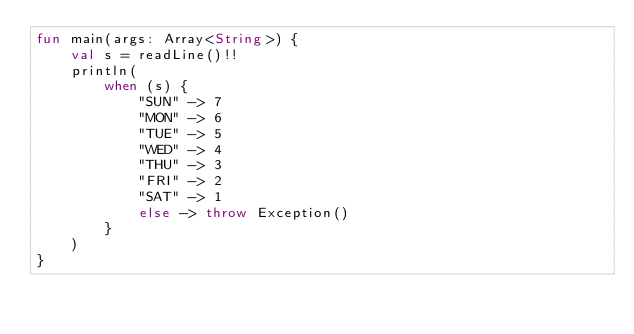<code> <loc_0><loc_0><loc_500><loc_500><_Kotlin_>fun main(args: Array<String>) {
    val s = readLine()!!
    println(
        when (s) {
            "SUN" -> 7
            "MON" -> 6
            "TUE" -> 5
            "WED" -> 4
            "THU" -> 3
            "FRI" -> 2
            "SAT" -> 1
            else -> throw Exception()
        }
    )
}</code> 